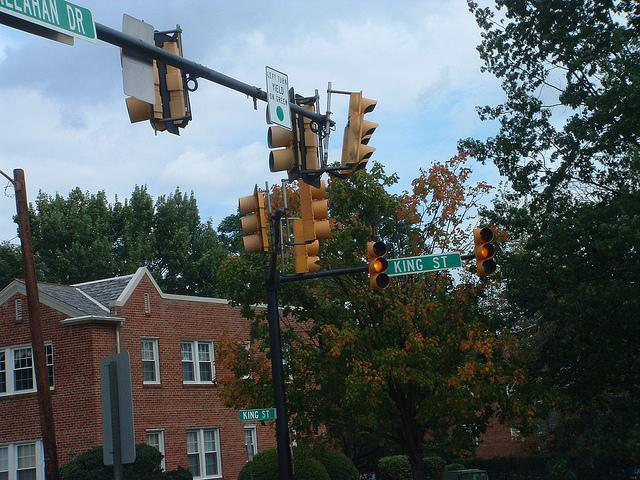Who would be married to the person that is listed on the street name? Please explain your reasoning. queen. This is the highest-ranked female royal title. 